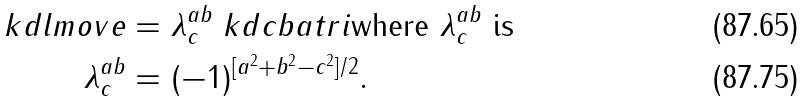Convert formula to latex. <formula><loc_0><loc_0><loc_500><loc_500>\ k d { l m o v e } & = \lambda ^ { a b } _ { c } \ k d { c b a t r i } \text {where $\lambda^{ab}_{c}$ is} \\ \lambda ^ { a b } _ { c } & = ( - 1 ) ^ { [ a ^ { 2 } + b ^ { 2 } - c ^ { 2 } ] / 2 } .</formula> 